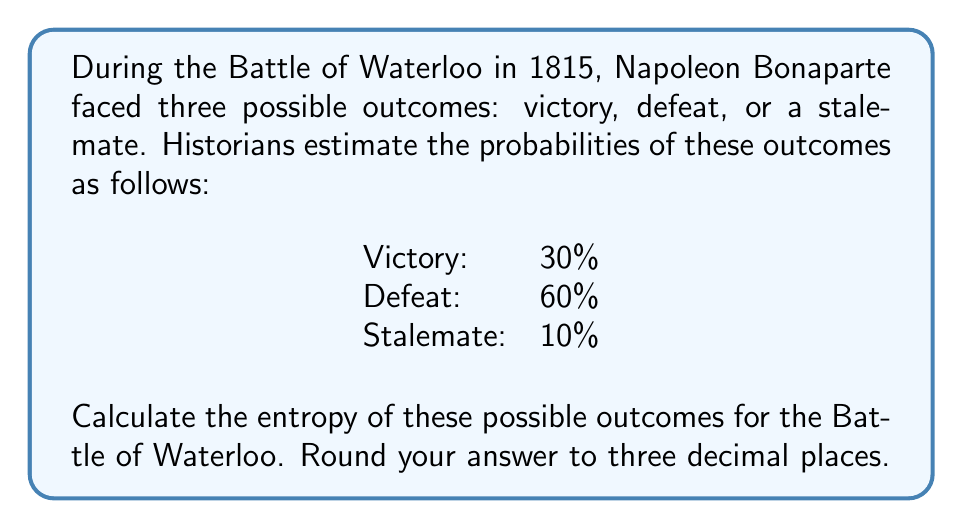What is the answer to this math problem? To calculate the entropy of this historical event's possible outcomes, we'll use the formula for Shannon entropy:

$$H = -\sum_{i=1}^{n} p_i \log_2(p_i)$$

Where:
$H$ is the entropy
$p_i$ is the probability of each outcome
$n$ is the number of possible outcomes

Let's break this down step-by-step:

1. Identify the probabilities:
   $p_1 = 0.30$ (Victory)
   $p_2 = 0.60$ (Defeat)
   $p_3 = 0.10$ (Stalemate)

2. Calculate each term of the sum:
   For Victory: $-0.30 \log_2(0.30) = -0.30 \times (-1.737) = 0.521$
   For Defeat: $-0.60 \log_2(0.60) = -0.60 \times (-0.737) = 0.442$
   For Stalemate: $-0.10 \log_2(0.10) = -0.10 \times (-3.322) = 0.332$

3. Sum up all the terms:
   $H = 0.521 + 0.442 + 0.332 = 1.295$

4. Round to three decimal places:
   $H \approx 1.295$ bits

This entropy value represents the average amount of information or uncertainty in the Battle of Waterloo's outcome. A higher entropy would indicate more uncertainty or unpredictability in the event's outcome.
Answer: The entropy of the possible outcomes for the Battle of Waterloo is approximately 1.295 bits. 